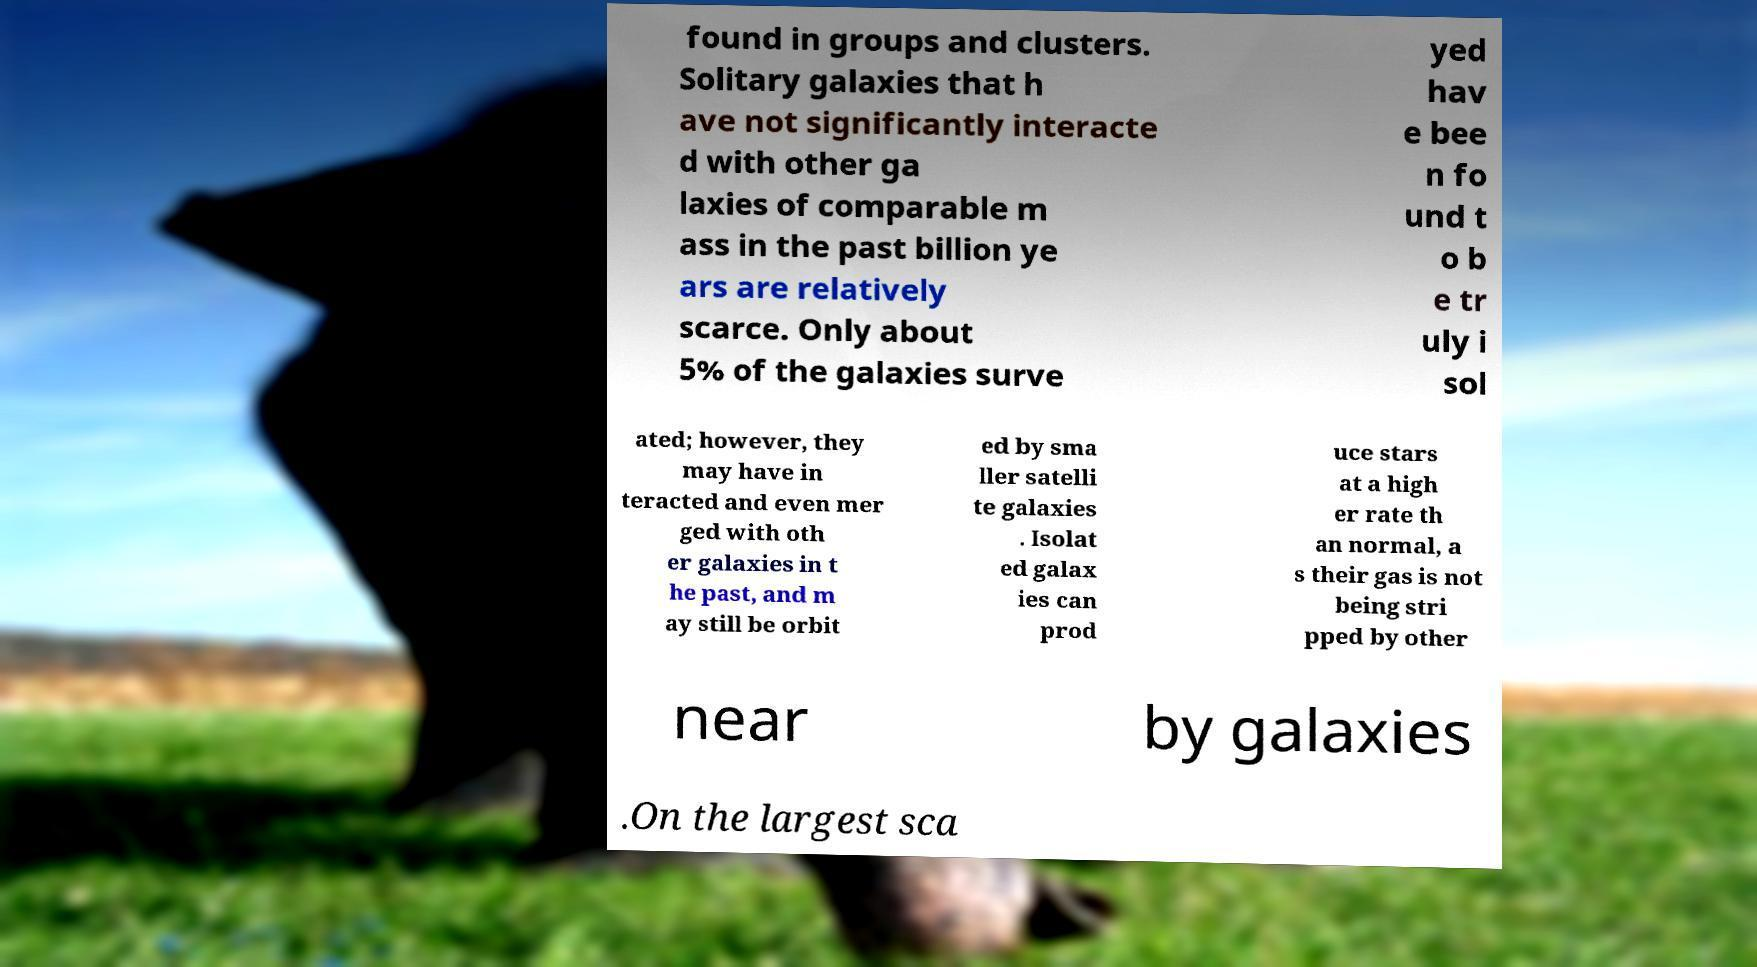Please identify and transcribe the text found in this image. found in groups and clusters. Solitary galaxies that h ave not significantly interacte d with other ga laxies of comparable m ass in the past billion ye ars are relatively scarce. Only about 5% of the galaxies surve yed hav e bee n fo und t o b e tr uly i sol ated; however, they may have in teracted and even mer ged with oth er galaxies in t he past, and m ay still be orbit ed by sma ller satelli te galaxies . Isolat ed galax ies can prod uce stars at a high er rate th an normal, a s their gas is not being stri pped by other near by galaxies .On the largest sca 